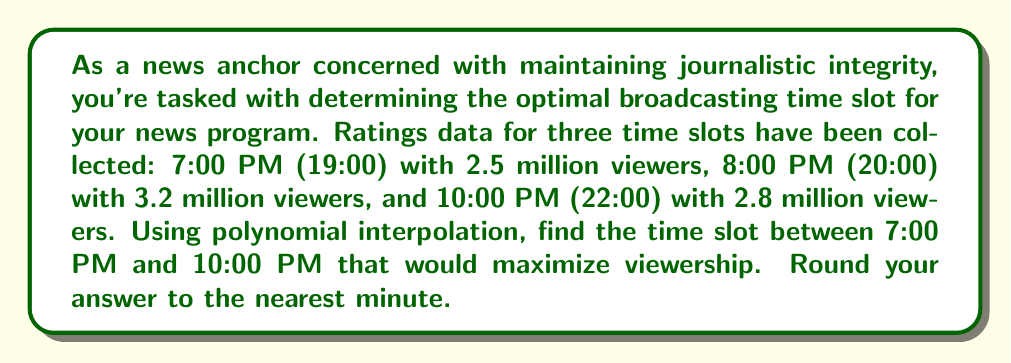What is the answer to this math problem? To solve this problem, we'll use polynomial interpolation to create a quadratic function that fits the given data points. Then, we'll find the maximum of this function to determine the optimal time slot.

1. Let's define our variables:
   $x$: time in hours after 7:00 PM
   $y$: number of viewers in millions

2. Our data points are:
   $(0, 2.5)$, $(1, 3.2)$, $(3, 2.8)$

3. We'll use the general form of a quadratic equation:
   $y = ax^2 + bx + c$

4. Substituting our data points:
   $2.5 = a(0)^2 + b(0) + c$
   $3.2 = a(1)^2 + b(1) + c$
   $2.8 = a(3)^2 + b(3) + c$

5. Simplifying:
   $2.5 = c$
   $3.2 = a + b + 2.5$
   $2.8 = 9a + 3b + 2.5$

6. Solving this system of equations:
   $c = 2.5$
   $a + b = 0.7$
   $9a + 3b = 0.3$

   Subtracting 3 times the second equation from the third:
   $6a = -1.8$
   $a = -0.3$

   Substituting back:
   $b = 0.7 - (-0.3) = 1$

7. Our interpolation polynomial is:
   $y = -0.3x^2 + x + 2.5$

8. To find the maximum, we differentiate and set to zero:
   $\frac{dy}{dx} = -0.6x + 1 = 0$
   $x = \frac{5}{3} = 1.667$ hours after 7:00 PM

9. Converting to clock time:
   7:00 PM + 1 hour 40 minutes = 8:40 PM

10. Verifying the maximum:
    $\frac{d^2y}{dx^2} = -0.6 < 0$, confirming it's a maximum
Answer: The optimal broadcasting time slot is 8:40 PM (20:40). 